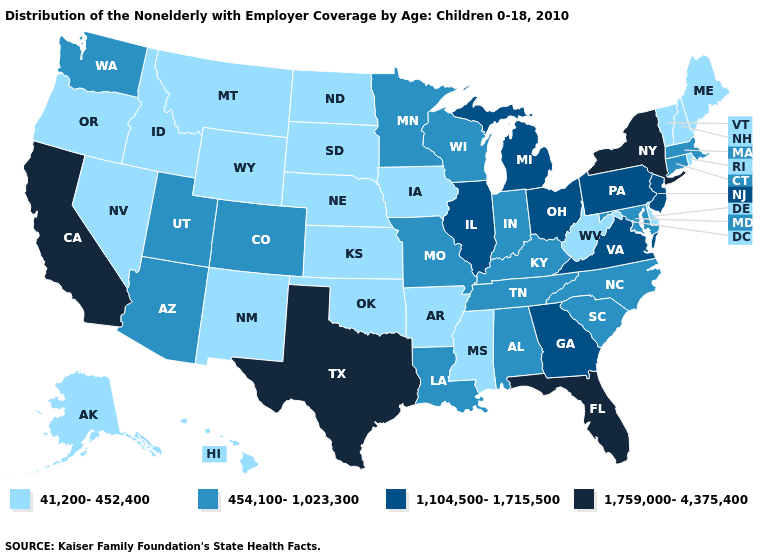What is the value of Kentucky?
Give a very brief answer. 454,100-1,023,300. Name the states that have a value in the range 1,759,000-4,375,400?
Give a very brief answer. California, Florida, New York, Texas. Does Texas have the highest value in the USA?
Write a very short answer. Yes. Does West Virginia have the highest value in the South?
Write a very short answer. No. Does Missouri have the same value as New Hampshire?
Keep it brief. No. What is the highest value in the MidWest ?
Be succinct. 1,104,500-1,715,500. What is the lowest value in states that border Arkansas?
Concise answer only. 41,200-452,400. What is the lowest value in the USA?
Short answer required. 41,200-452,400. Which states have the lowest value in the MidWest?
Answer briefly. Iowa, Kansas, Nebraska, North Dakota, South Dakota. What is the lowest value in the USA?
Give a very brief answer. 41,200-452,400. Does California have the highest value in the West?
Concise answer only. Yes. What is the value of Minnesota?
Quick response, please. 454,100-1,023,300. Which states have the lowest value in the USA?
Give a very brief answer. Alaska, Arkansas, Delaware, Hawaii, Idaho, Iowa, Kansas, Maine, Mississippi, Montana, Nebraska, Nevada, New Hampshire, New Mexico, North Dakota, Oklahoma, Oregon, Rhode Island, South Dakota, Vermont, West Virginia, Wyoming. Does Vermont have the lowest value in the USA?
Keep it brief. Yes. What is the lowest value in the USA?
Keep it brief. 41,200-452,400. 